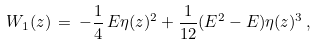<formula> <loc_0><loc_0><loc_500><loc_500>W _ { 1 } ( z ) \, = \, - \frac { 1 } { 4 } \, E \eta ( z ) ^ { 2 } + \frac { 1 } { 1 2 } ( E ^ { 2 } - E ) \eta ( z ) ^ { 3 } \, ,</formula> 